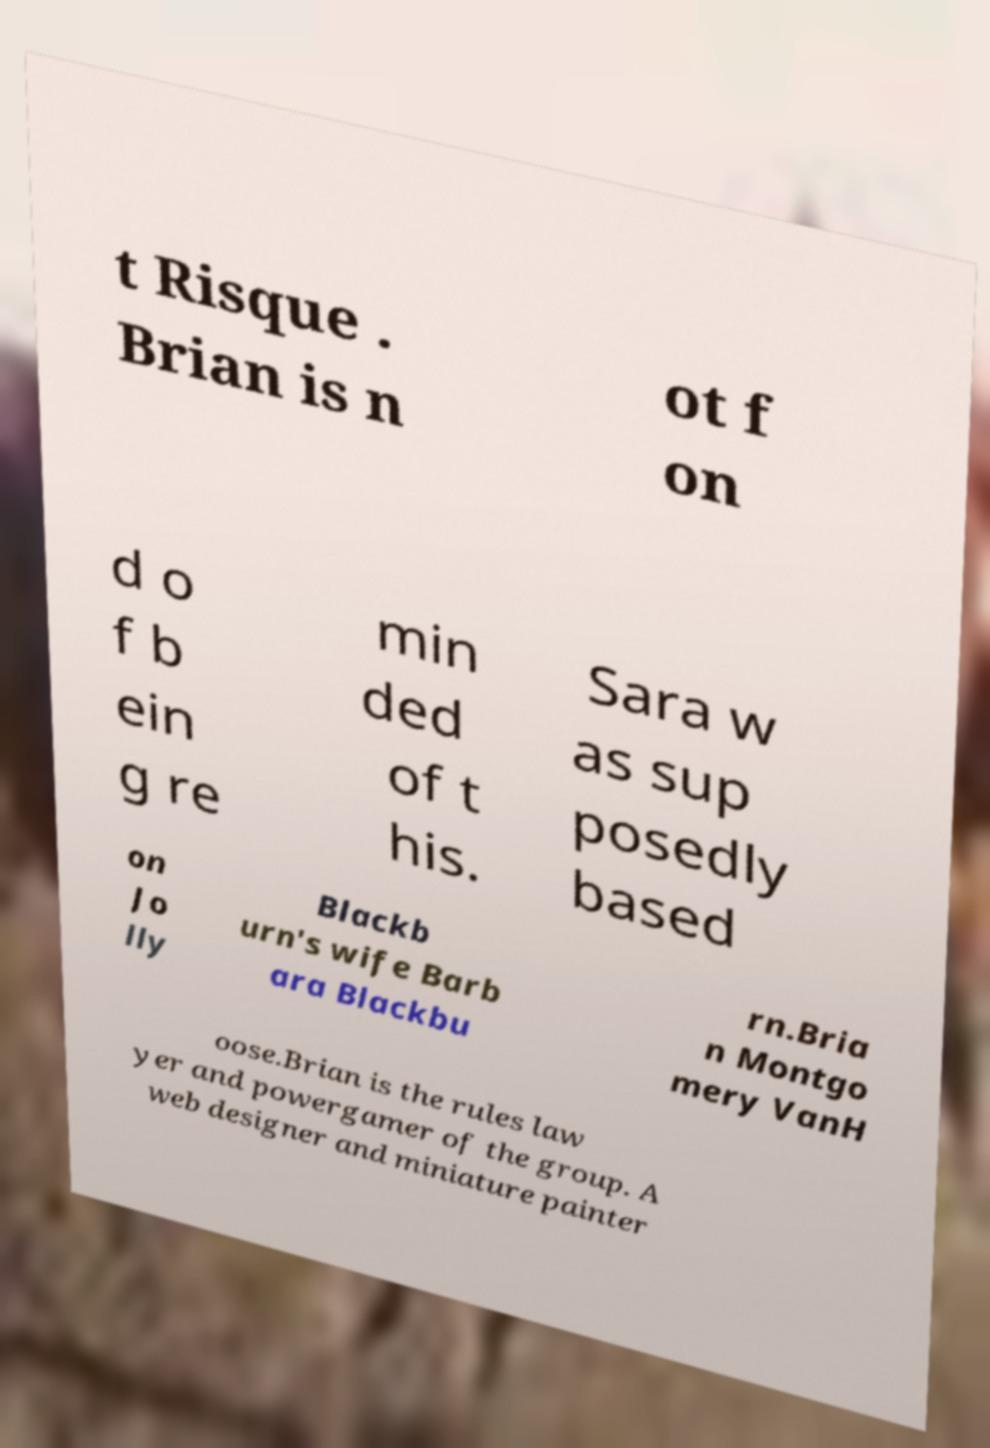There's text embedded in this image that I need extracted. Can you transcribe it verbatim? t Risque . Brian is n ot f on d o f b ein g re min ded of t his. Sara w as sup posedly based on Jo lly Blackb urn's wife Barb ara Blackbu rn.Bria n Montgo mery VanH oose.Brian is the rules law yer and powergamer of the group. A web designer and miniature painter 